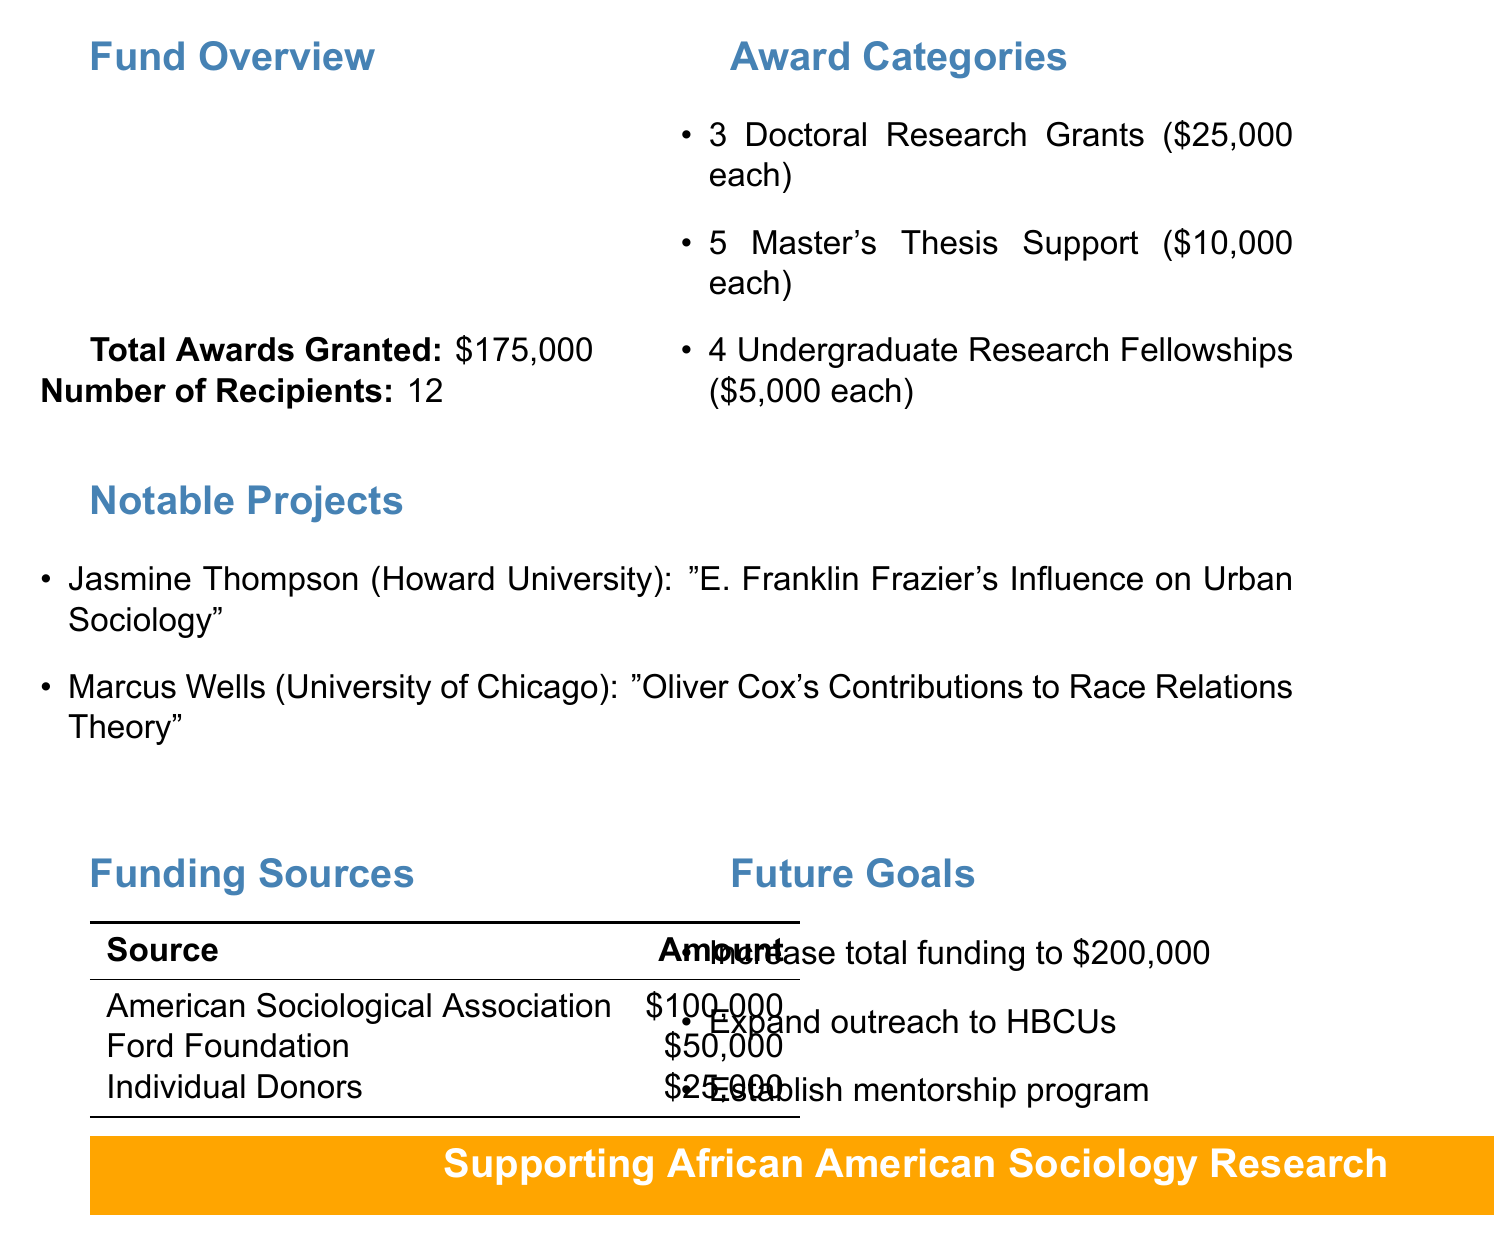What is the total amount of awards granted? The total amount of awards granted is explicitly stated in the fund report as $175,000.
Answer: $175,000 How many recipients received awards? The document specifies that the total number of recipients for the awards is 12.
Answer: 12 What is the amount of each Doctoral Research Grant? The report details that each Doctoral Research Grant is awarded in the amount of $25,000.
Answer: $25,000 Who is the student associated with the project on E. Franklin Frazier? The document lists Jasmine Thompson as the student working on the project about E. Franklin Frazier's influence.
Answer: Jasmine Thompson What is one of the future goals mentioned in the report? The document outlines several future goals, including increasing total funding to $200,000 for the next academic year.
Answer: Increase total funding to $200,000 How much funding did the American Sociological Association provide? According to the funding sources section, the American Sociological Association contributed $100,000.
Answer: $100,000 How many Master's Thesis Support awards were given? The document states that 5 Master's Thesis Support awards were granted.
Answer: 5 What is the funding source with the least amount contributed? The report shows that Individual Donors provided the least amount, which is $25,000.
Answer: Individual Donors What type of funding is designated for the most recipients? The report indicates that the Master's Thesis Support category has the highest number of recipients, totaling 5.
Answer: Master's Thesis Support 